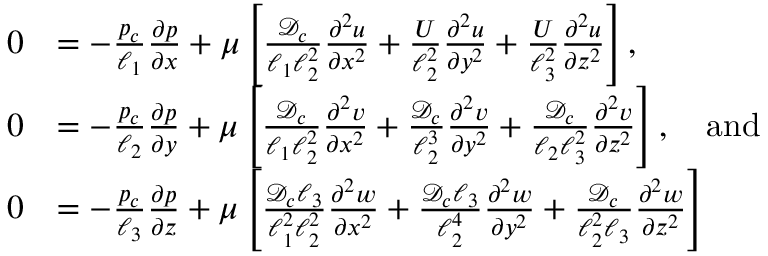<formula> <loc_0><loc_0><loc_500><loc_500>\begin{array} { r l } { 0 } & { = - \frac { p _ { c } } { \ell _ { 1 } } \frac { \partial p } { \partial x } + \mu \left [ \frac { { \mathcal { D } } _ { c } } { \ell _ { 1 } \ell _ { 2 } ^ { 2 } } \frac { \partial ^ { 2 } u } { \partial x ^ { 2 } } + \frac { U } { \ell _ { 2 } ^ { 2 } } \frac { \partial ^ { 2 } u } { \partial y ^ { 2 } } + \frac { U } { \ell _ { 3 } ^ { 2 } } \frac { \partial ^ { 2 } u } { \partial z ^ { 2 } } \right ] , } \\ { 0 } & { = - \frac { p _ { c } } { \ell _ { 2 } } \frac { \partial p } { \partial y } + \mu \left [ \frac { { \mathcal { D } } _ { c } } { \ell _ { 1 } \ell _ { 2 } ^ { 2 } } \frac { \partial ^ { 2 } v } { \partial x ^ { 2 } } + \frac { { \mathcal { D } } _ { c } } { \ell _ { 2 } ^ { 3 } } \frac { \partial ^ { 2 } v } { \partial y ^ { 2 } } + \frac { { \mathcal { D } } _ { c } } { \ell _ { 2 } \ell _ { 3 } ^ { 2 } } \frac { \partial ^ { 2 } v } { \partial z ^ { 2 } } \right ] , \quad a n d } \\ { 0 } & { = - \frac { p _ { c } } { \ell _ { 3 } } \frac { \partial p } { \partial z } + \mu \left [ \frac { { \mathcal { D } } _ { c } \ell _ { 3 } } { \ell _ { 1 } ^ { 2 } \ell _ { 2 } ^ { 2 } } \frac { \partial ^ { 2 } w } { \partial x ^ { 2 } } + \frac { { \mathcal { D } } _ { c } \ell _ { 3 } } { \ell _ { 2 } ^ { 4 } } \frac { \partial ^ { 2 } w } { \partial y ^ { 2 } } + \frac { { \mathcal { D } } _ { c } } { \ell _ { 2 } ^ { 2 } \ell _ { 3 } } \frac { \partial ^ { 2 } w } { \partial z ^ { 2 } } \right ] } \end{array}</formula> 